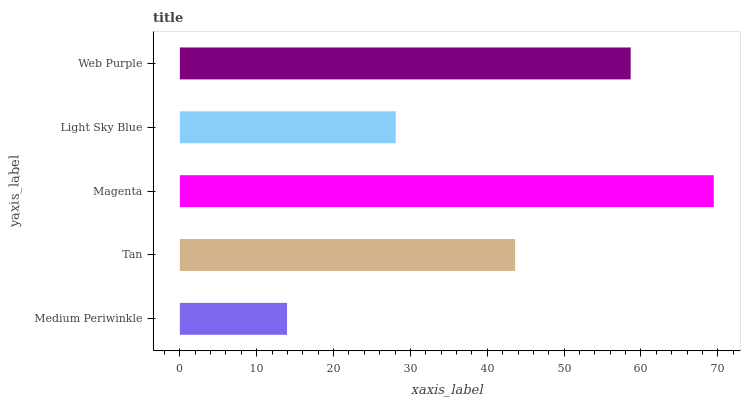Is Medium Periwinkle the minimum?
Answer yes or no. Yes. Is Magenta the maximum?
Answer yes or no. Yes. Is Tan the minimum?
Answer yes or no. No. Is Tan the maximum?
Answer yes or no. No. Is Tan greater than Medium Periwinkle?
Answer yes or no. Yes. Is Medium Periwinkle less than Tan?
Answer yes or no. Yes. Is Medium Periwinkle greater than Tan?
Answer yes or no. No. Is Tan less than Medium Periwinkle?
Answer yes or no. No. Is Tan the high median?
Answer yes or no. Yes. Is Tan the low median?
Answer yes or no. Yes. Is Web Purple the high median?
Answer yes or no. No. Is Web Purple the low median?
Answer yes or no. No. 